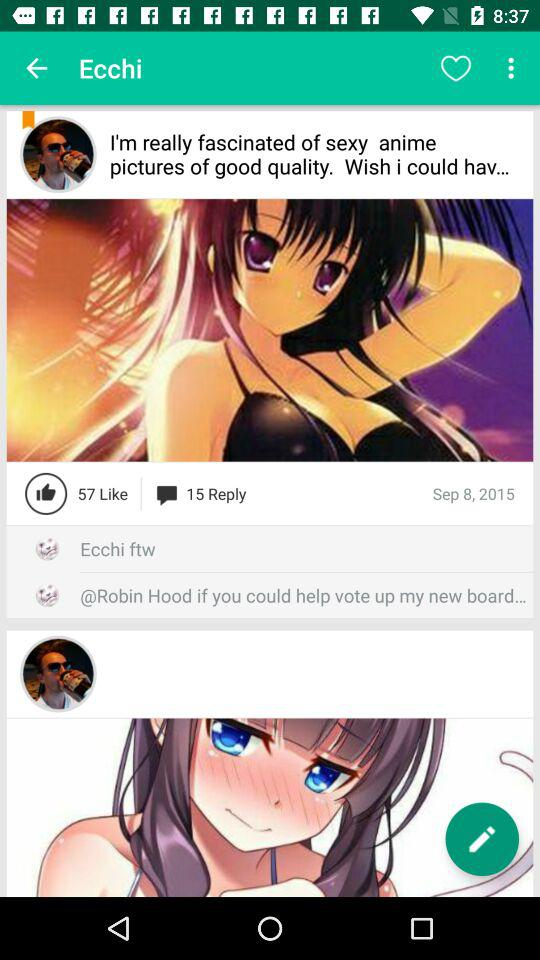How many likes are there on "anime pictures" posted? There are 57 likes. 